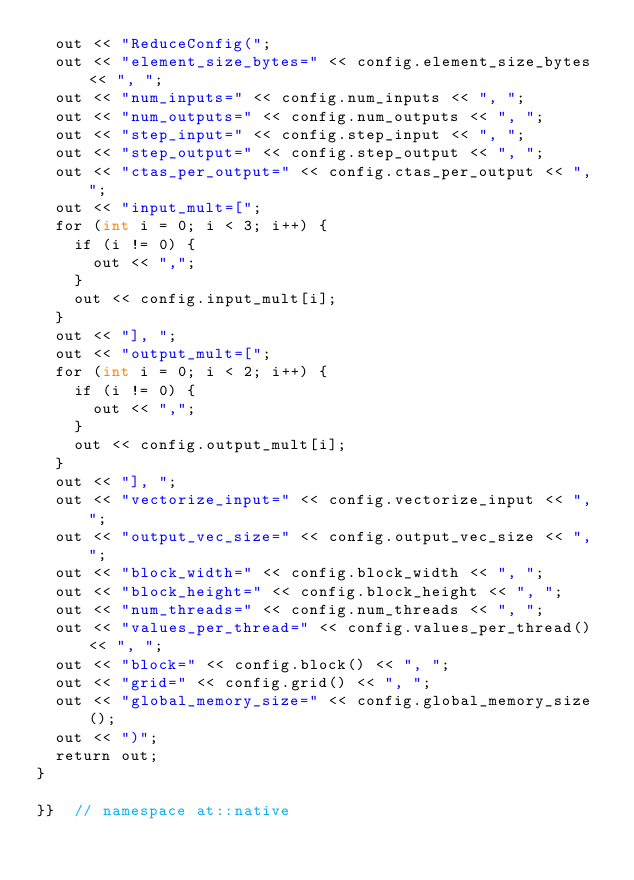Convert code to text. <code><loc_0><loc_0><loc_500><loc_500><_Cuda_>  out << "ReduceConfig(";
  out << "element_size_bytes=" << config.element_size_bytes << ", ";
  out << "num_inputs=" << config.num_inputs << ", ";
  out << "num_outputs=" << config.num_outputs << ", ";
  out << "step_input=" << config.step_input << ", ";
  out << "step_output=" << config.step_output << ", ";
  out << "ctas_per_output=" << config.ctas_per_output << ", ";
  out << "input_mult=[";
  for (int i = 0; i < 3; i++) {
    if (i != 0) {
      out << ",";
    }
    out << config.input_mult[i];
  }
  out << "], ";
  out << "output_mult=[";
  for (int i = 0; i < 2; i++) {
    if (i != 0) {
      out << ",";
    }
    out << config.output_mult[i];
  }
  out << "], ";
  out << "vectorize_input=" << config.vectorize_input << ", ";
  out << "output_vec_size=" << config.output_vec_size << ", ";
  out << "block_width=" << config.block_width << ", ";
  out << "block_height=" << config.block_height << ", ";
  out << "num_threads=" << config.num_threads << ", ";
  out << "values_per_thread=" << config.values_per_thread() << ", ";
  out << "block=" << config.block() << ", ";
  out << "grid=" << config.grid() << ", ";
  out << "global_memory_size=" << config.global_memory_size();
  out << ")";
  return out;
}

}}  // namespace at::native
</code> 